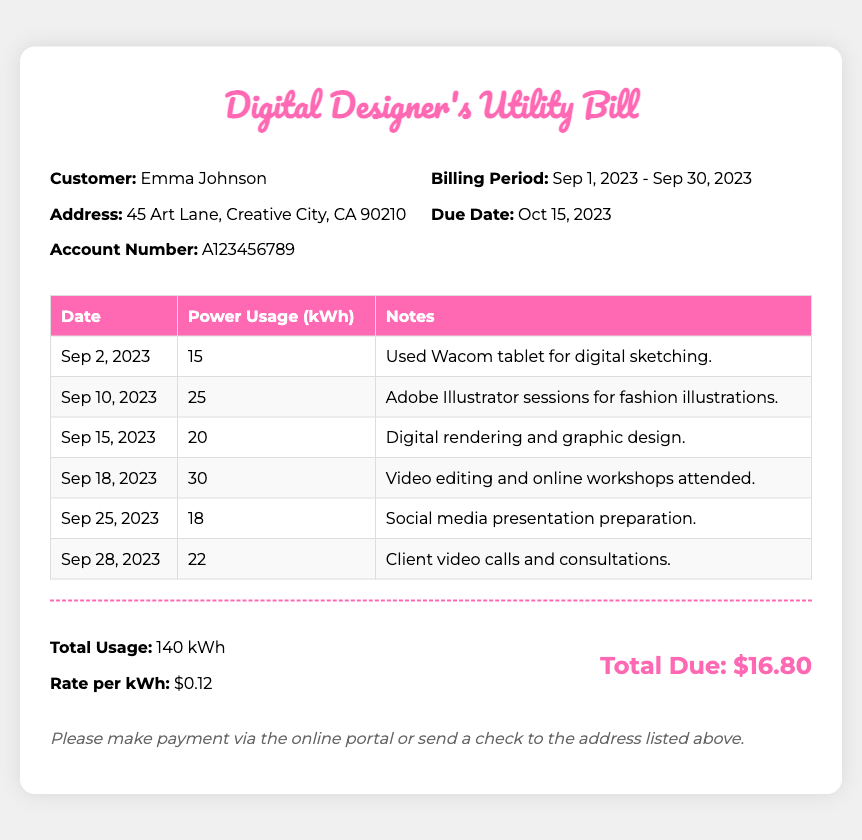What is the customer's name? The document specifies the customer's name at the top, which is Emma Johnson.
Answer: Emma Johnson What is the billing period? This is mentioned in the customer info section, it states that the billing period is from September 1 to September 30, 2023.
Answer: Sep 1, 2023 - Sep 30, 2023 What was the power usage on September 10, 2023? The power usage for that specific date is provided in the usage table, which shows 25 kWh.
Answer: 25 kWh How much is the rate per kWh? The rate per kWh is detailed in the total section of the bill, indicating that it is $0.12.
Answer: $0.12 What is the total due amount? The total amount due is presented at the end of the document, calculated to be $16.80.
Answer: $16.80 What tool was used for digital sketching on September 2? The document notes that a Wacom tablet was used for digital sketching on that date.
Answer: Wacom tablet Which activity had the highest power usage? By reviewing the usage table, the activity on September 18 for video editing and online workshops had 30 kWh, which is the highest.
Answer: Video editing and online workshops How many times was Adobe Illustrator used during the billing period? The usage table lists one specific session for Adobe Illustrator, indicating it was used once.
Answer: Once What is the address of the customer? The customer’s address is specified in the customer info section as 45 Art Lane, Creative City, CA 90210.
Answer: 45 Art Lane, Creative City, CA 90210 